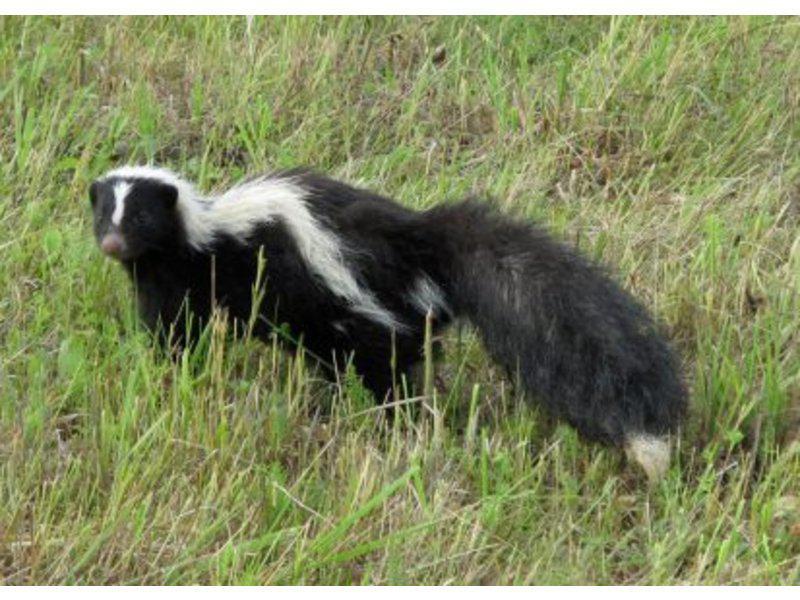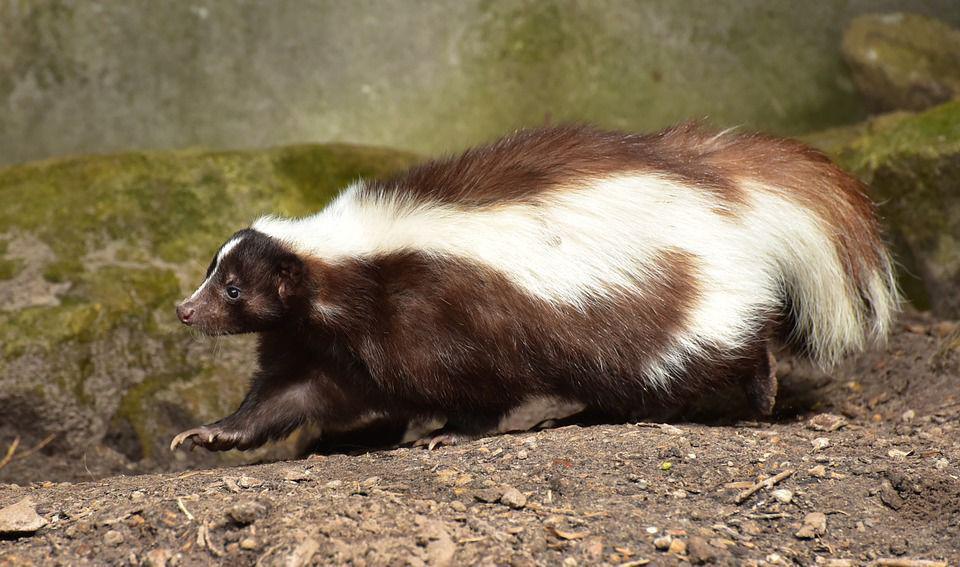The first image is the image on the left, the second image is the image on the right. Assess this claim about the two images: "In at least one image there is a black and white skunk in the grass with its body facing left.". Correct or not? Answer yes or no. Yes. The first image is the image on the left, the second image is the image on the right. Considering the images on both sides, is "The skunk on the left is standing still and looking forward, and the skunk on the right is trotting in a horizontal path." valid? Answer yes or no. Yes. 